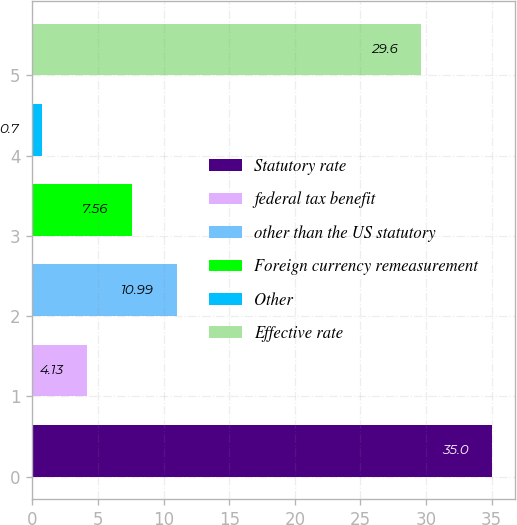<chart> <loc_0><loc_0><loc_500><loc_500><bar_chart><fcel>Statutory rate<fcel>federal tax benefit<fcel>other than the US statutory<fcel>Foreign currency remeasurement<fcel>Other<fcel>Effective rate<nl><fcel>35<fcel>4.13<fcel>10.99<fcel>7.56<fcel>0.7<fcel>29.6<nl></chart> 